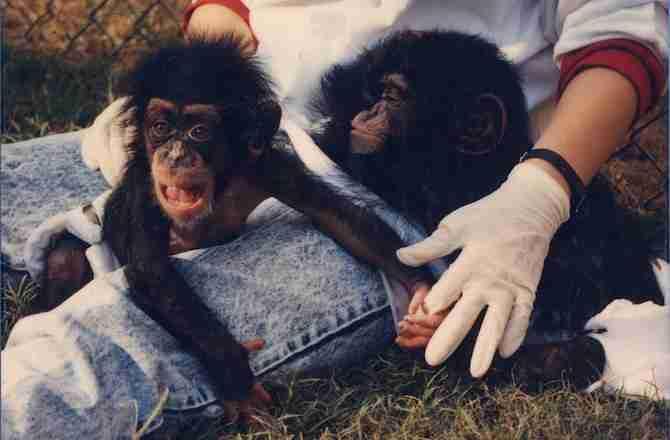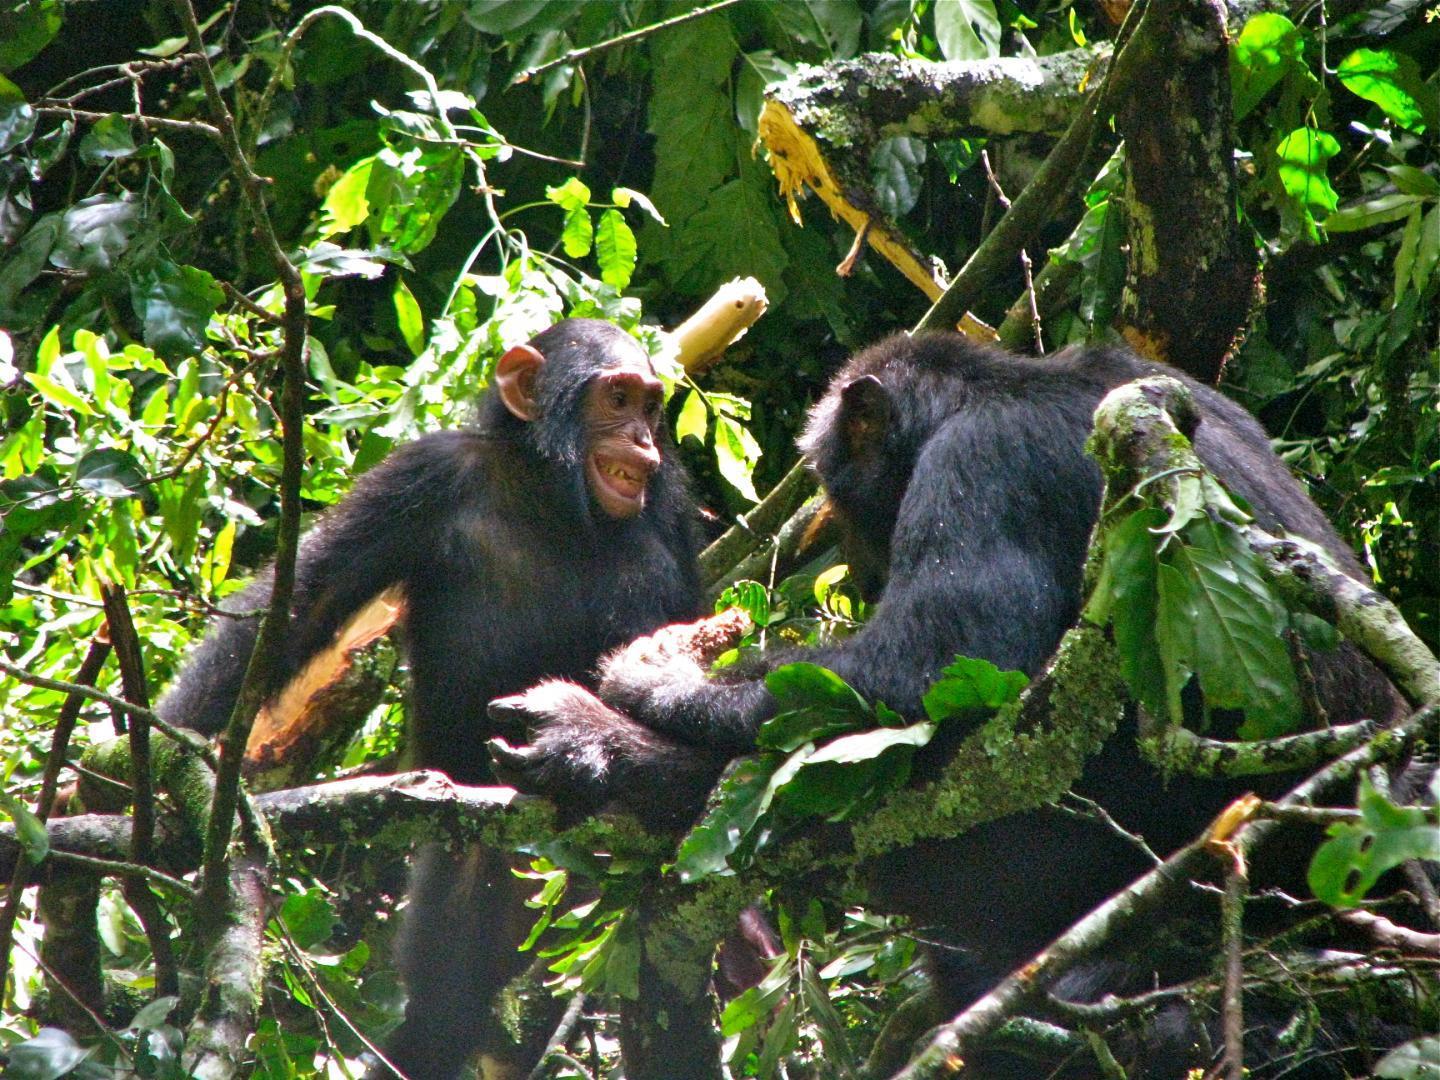The first image is the image on the left, the second image is the image on the right. Given the left and right images, does the statement "The image on the right features only one chimp." hold true? Answer yes or no. No. 